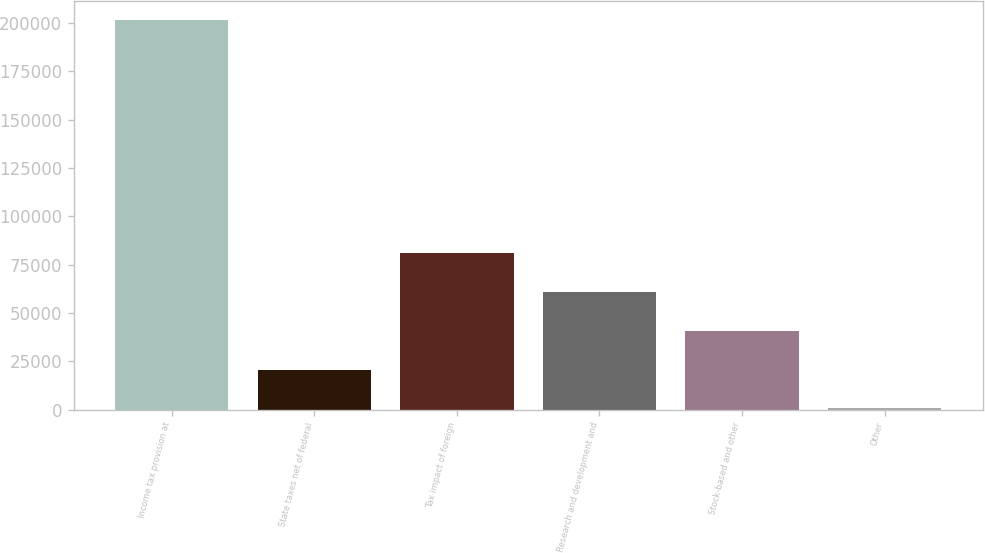Convert chart. <chart><loc_0><loc_0><loc_500><loc_500><bar_chart><fcel>Income tax provision at<fcel>State taxes net of federal<fcel>Tax impact of foreign<fcel>Research and development and<fcel>Stock-based and other<fcel>Other<nl><fcel>201431<fcel>20687.6<fcel>80935.4<fcel>60852.8<fcel>40770.2<fcel>605<nl></chart> 